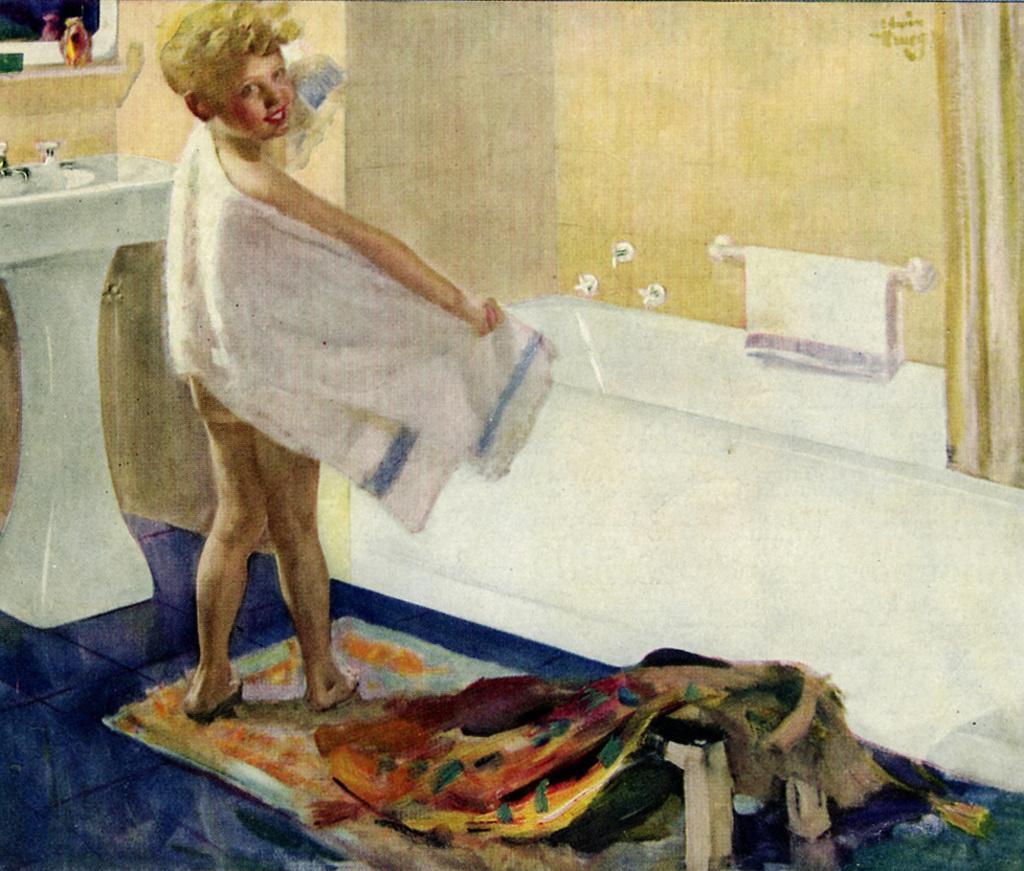In one or two sentences, can you explain what this image depicts? In this image i can see one person standing, there is bathing tub, wash basin and few objects on it, towel, there is a floor mat, i can see the wall. 